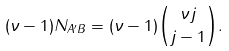Convert formula to latex. <formula><loc_0><loc_0><loc_500><loc_500>( \nu - 1 ) N _ { A ^ { \prime } B } = ( \nu - 1 ) \binom { \nu j } { j - 1 } .</formula> 